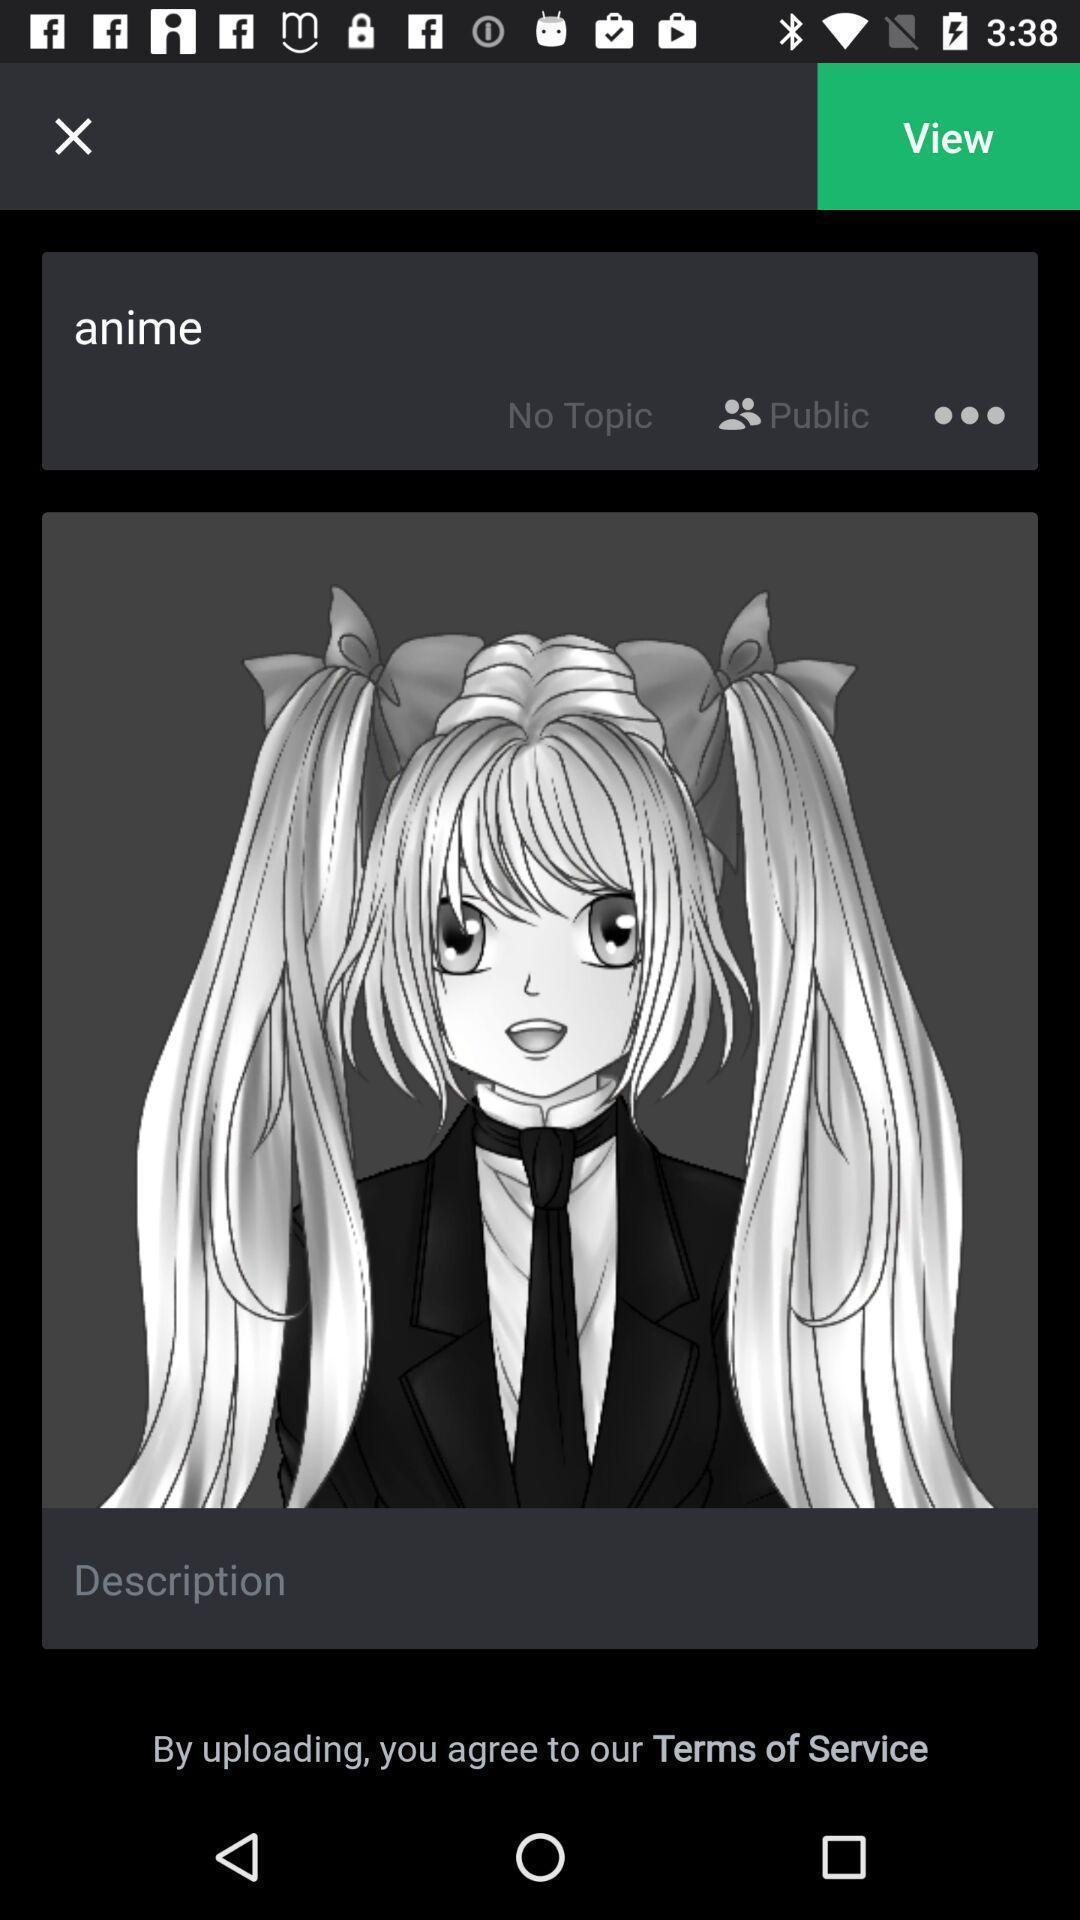Explain the elements present in this screenshot. Screen shows an image. 